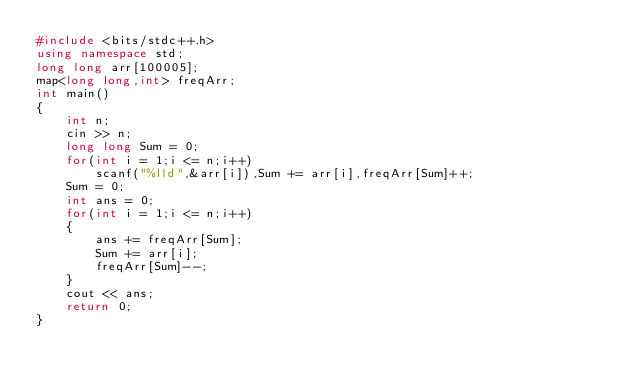Convert code to text. <code><loc_0><loc_0><loc_500><loc_500><_C++_>#include <bits/stdc++.h>
using namespace std;
long long arr[100005];
map<long long,int> freqArr;
int main()
{
    int n;
    cin >> n;
    long long Sum = 0;
    for(int i = 1;i <= n;i++)
        scanf("%lld",&arr[i]),Sum += arr[i],freqArr[Sum]++;
    Sum = 0;
    int ans = 0;
    for(int i = 1;i <= n;i++)
    {
        ans += freqArr[Sum];
        Sum += arr[i];
        freqArr[Sum]--;
    }
    cout << ans;
    return 0;
}
</code> 